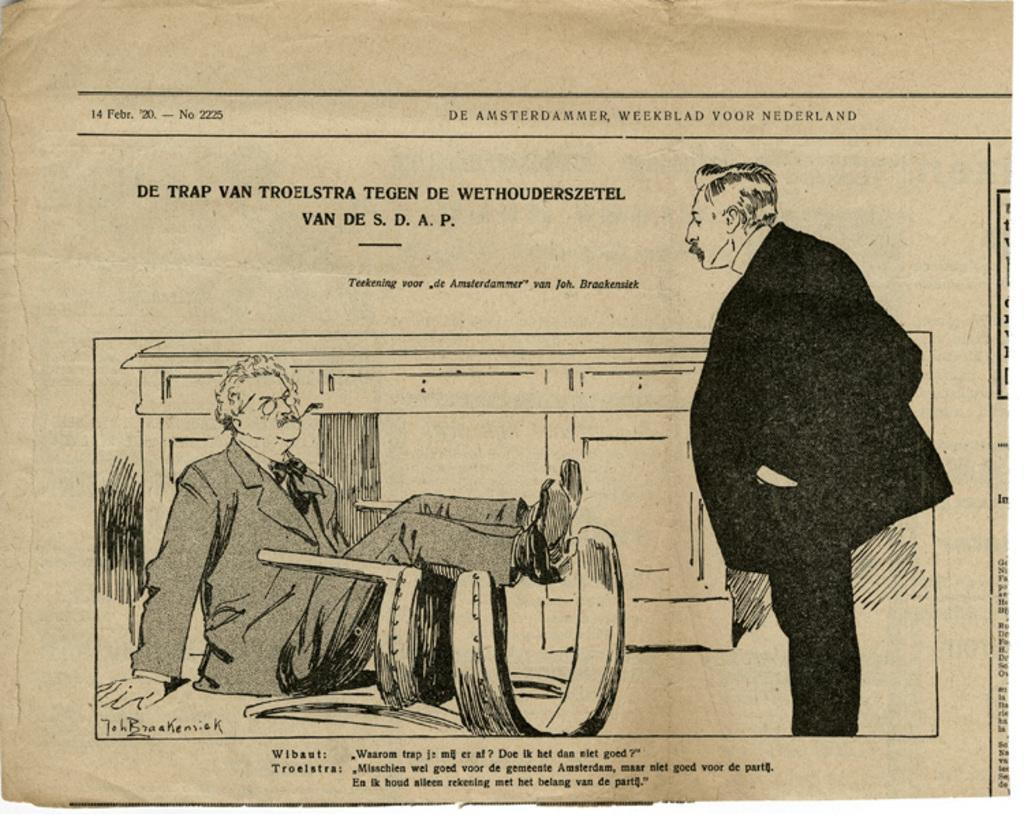What is the main subject of the image? There is a drawing in the image. Can you describe the people in the image? There are persons in the image. What type of furniture is present in the image? There is a chair in the image. Are there any storage units in the image? Yes, there is a cupboard in the image. What is written at the top of the image? There is text at the top of the image. What is written at the bottom of the image? There is text at the bottom of the image. What is the value of the insurance policy mentioned in the image? There is no mention of an insurance policy in the image. What activities are the persons in the image participating in during the summer? The image does not depict any specific season or activities related to summer. 